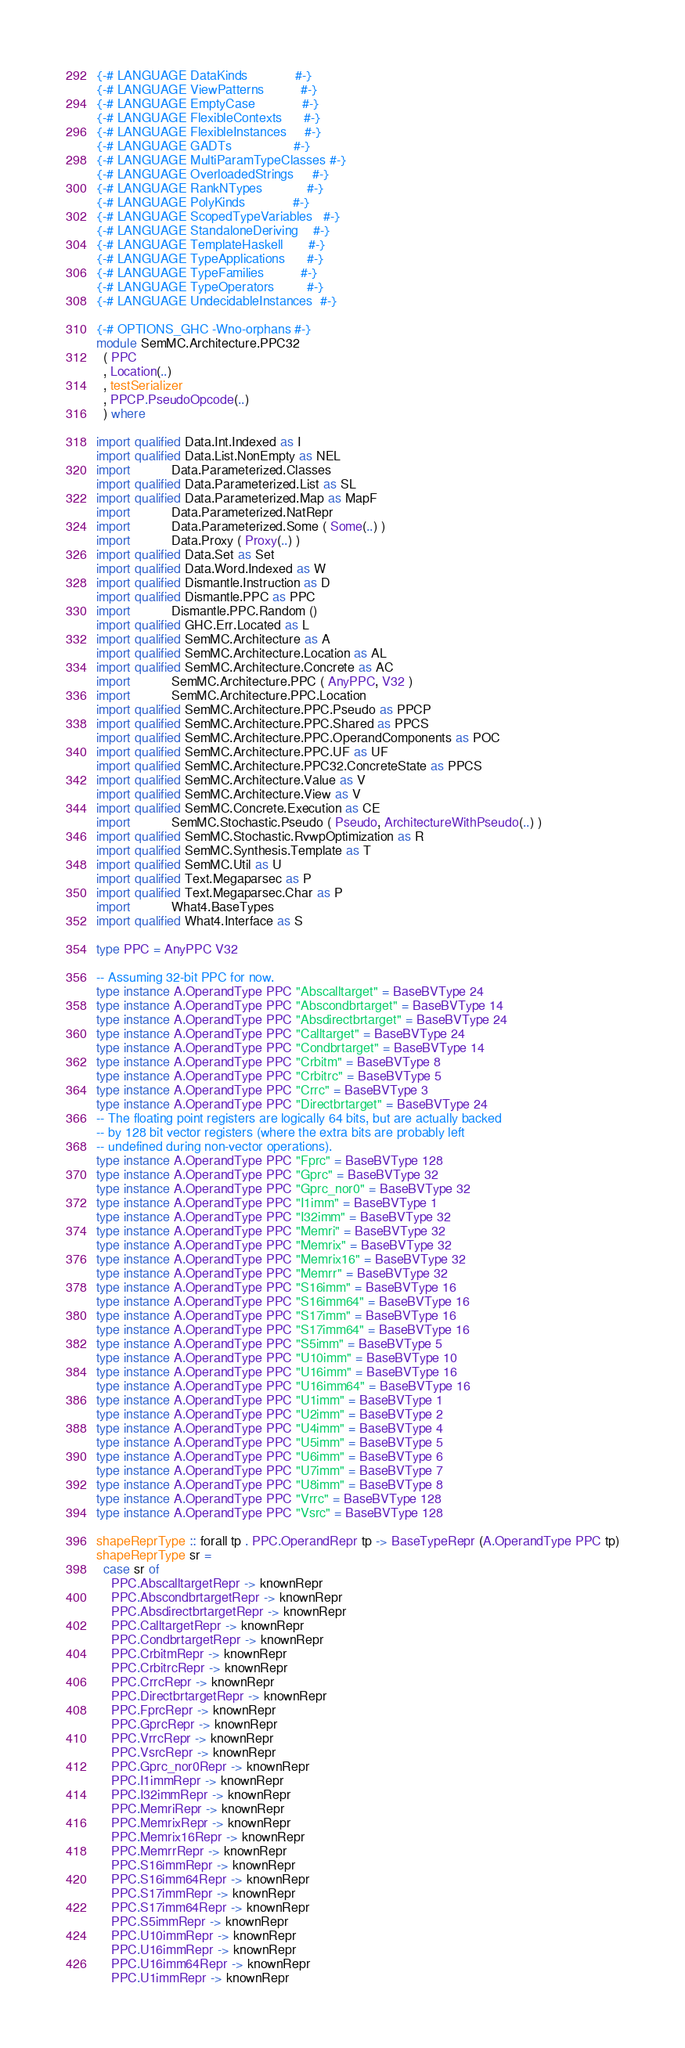Convert code to text. <code><loc_0><loc_0><loc_500><loc_500><_Haskell_>{-# LANGUAGE DataKinds             #-}
{-# LANGUAGE ViewPatterns          #-}
{-# LANGUAGE EmptyCase             #-}
{-# LANGUAGE FlexibleContexts      #-}
{-# LANGUAGE FlexibleInstances     #-}
{-# LANGUAGE GADTs                 #-}
{-# LANGUAGE MultiParamTypeClasses #-}
{-# LANGUAGE OverloadedStrings     #-}
{-# LANGUAGE RankNTypes            #-}
{-# LANGUAGE PolyKinds             #-}
{-# LANGUAGE ScopedTypeVariables   #-}
{-# LANGUAGE StandaloneDeriving    #-}
{-# LANGUAGE TemplateHaskell       #-}
{-# LANGUAGE TypeApplications      #-}
{-# LANGUAGE TypeFamilies          #-}
{-# LANGUAGE TypeOperators         #-}
{-# LANGUAGE UndecidableInstances  #-}

{-# OPTIONS_GHC -Wno-orphans #-}
module SemMC.Architecture.PPC32
  ( PPC
  , Location(..)
  , testSerializer
  , PPCP.PseudoOpcode(..)
  ) where

import qualified Data.Int.Indexed as I
import qualified Data.List.NonEmpty as NEL
import           Data.Parameterized.Classes
import qualified Data.Parameterized.List as SL
import qualified Data.Parameterized.Map as MapF
import           Data.Parameterized.NatRepr
import           Data.Parameterized.Some ( Some(..) )
import           Data.Proxy ( Proxy(..) )
import qualified Data.Set as Set
import qualified Data.Word.Indexed as W
import qualified Dismantle.Instruction as D
import qualified Dismantle.PPC as PPC
import           Dismantle.PPC.Random ()
import qualified GHC.Err.Located as L
import qualified SemMC.Architecture as A
import qualified SemMC.Architecture.Location as AL
import qualified SemMC.Architecture.Concrete as AC
import           SemMC.Architecture.PPC ( AnyPPC, V32 )
import           SemMC.Architecture.PPC.Location
import qualified SemMC.Architecture.PPC.Pseudo as PPCP
import qualified SemMC.Architecture.PPC.Shared as PPCS
import qualified SemMC.Architecture.PPC.OperandComponents as POC
import qualified SemMC.Architecture.PPC.UF as UF
import qualified SemMC.Architecture.PPC32.ConcreteState as PPCS
import qualified SemMC.Architecture.Value as V
import qualified SemMC.Architecture.View as V
import qualified SemMC.Concrete.Execution as CE
import           SemMC.Stochastic.Pseudo ( Pseudo, ArchitectureWithPseudo(..) )
import qualified SemMC.Stochastic.RvwpOptimization as R
import qualified SemMC.Synthesis.Template as T
import qualified SemMC.Util as U
import qualified Text.Megaparsec as P
import qualified Text.Megaparsec.Char as P
import           What4.BaseTypes
import qualified What4.Interface as S

type PPC = AnyPPC V32

-- Assuming 32-bit PPC for now.
type instance A.OperandType PPC "Abscalltarget" = BaseBVType 24
type instance A.OperandType PPC "Abscondbrtarget" = BaseBVType 14
type instance A.OperandType PPC "Absdirectbrtarget" = BaseBVType 24
type instance A.OperandType PPC "Calltarget" = BaseBVType 24
type instance A.OperandType PPC "Condbrtarget" = BaseBVType 14
type instance A.OperandType PPC "Crbitm" = BaseBVType 8
type instance A.OperandType PPC "Crbitrc" = BaseBVType 5
type instance A.OperandType PPC "Crrc" = BaseBVType 3
type instance A.OperandType PPC "Directbrtarget" = BaseBVType 24
-- The floating point registers are logically 64 bits, but are actually backed
-- by 128 bit vector registers (where the extra bits are probably left
-- undefined during non-vector operations).
type instance A.OperandType PPC "Fprc" = BaseBVType 128
type instance A.OperandType PPC "Gprc" = BaseBVType 32
type instance A.OperandType PPC "Gprc_nor0" = BaseBVType 32
type instance A.OperandType PPC "I1imm" = BaseBVType 1
type instance A.OperandType PPC "I32imm" = BaseBVType 32
type instance A.OperandType PPC "Memri" = BaseBVType 32
type instance A.OperandType PPC "Memrix" = BaseBVType 32
type instance A.OperandType PPC "Memrix16" = BaseBVType 32
type instance A.OperandType PPC "Memrr" = BaseBVType 32
type instance A.OperandType PPC "S16imm" = BaseBVType 16
type instance A.OperandType PPC "S16imm64" = BaseBVType 16
type instance A.OperandType PPC "S17imm" = BaseBVType 16
type instance A.OperandType PPC "S17imm64" = BaseBVType 16
type instance A.OperandType PPC "S5imm" = BaseBVType 5
type instance A.OperandType PPC "U10imm" = BaseBVType 10
type instance A.OperandType PPC "U16imm" = BaseBVType 16
type instance A.OperandType PPC "U16imm64" = BaseBVType 16
type instance A.OperandType PPC "U1imm" = BaseBVType 1
type instance A.OperandType PPC "U2imm" = BaseBVType 2
type instance A.OperandType PPC "U4imm" = BaseBVType 4
type instance A.OperandType PPC "U5imm" = BaseBVType 5
type instance A.OperandType PPC "U6imm" = BaseBVType 6
type instance A.OperandType PPC "U7imm" = BaseBVType 7
type instance A.OperandType PPC "U8imm" = BaseBVType 8
type instance A.OperandType PPC "Vrrc" = BaseBVType 128
type instance A.OperandType PPC "Vsrc" = BaseBVType 128

shapeReprType :: forall tp . PPC.OperandRepr tp -> BaseTypeRepr (A.OperandType PPC tp)
shapeReprType sr =
  case sr of
    PPC.AbscalltargetRepr -> knownRepr
    PPC.AbscondbrtargetRepr -> knownRepr
    PPC.AbsdirectbrtargetRepr -> knownRepr
    PPC.CalltargetRepr -> knownRepr
    PPC.CondbrtargetRepr -> knownRepr
    PPC.CrbitmRepr -> knownRepr
    PPC.CrbitrcRepr -> knownRepr
    PPC.CrrcRepr -> knownRepr
    PPC.DirectbrtargetRepr -> knownRepr
    PPC.FprcRepr -> knownRepr
    PPC.GprcRepr -> knownRepr
    PPC.VrrcRepr -> knownRepr
    PPC.VsrcRepr -> knownRepr
    PPC.Gprc_nor0Repr -> knownRepr
    PPC.I1immRepr -> knownRepr
    PPC.I32immRepr -> knownRepr
    PPC.MemriRepr -> knownRepr
    PPC.MemrixRepr -> knownRepr
    PPC.Memrix16Repr -> knownRepr
    PPC.MemrrRepr -> knownRepr
    PPC.S16immRepr -> knownRepr
    PPC.S16imm64Repr -> knownRepr
    PPC.S17immRepr -> knownRepr
    PPC.S17imm64Repr -> knownRepr
    PPC.S5immRepr -> knownRepr
    PPC.U10immRepr -> knownRepr
    PPC.U16immRepr -> knownRepr
    PPC.U16imm64Repr -> knownRepr
    PPC.U1immRepr -> knownRepr</code> 